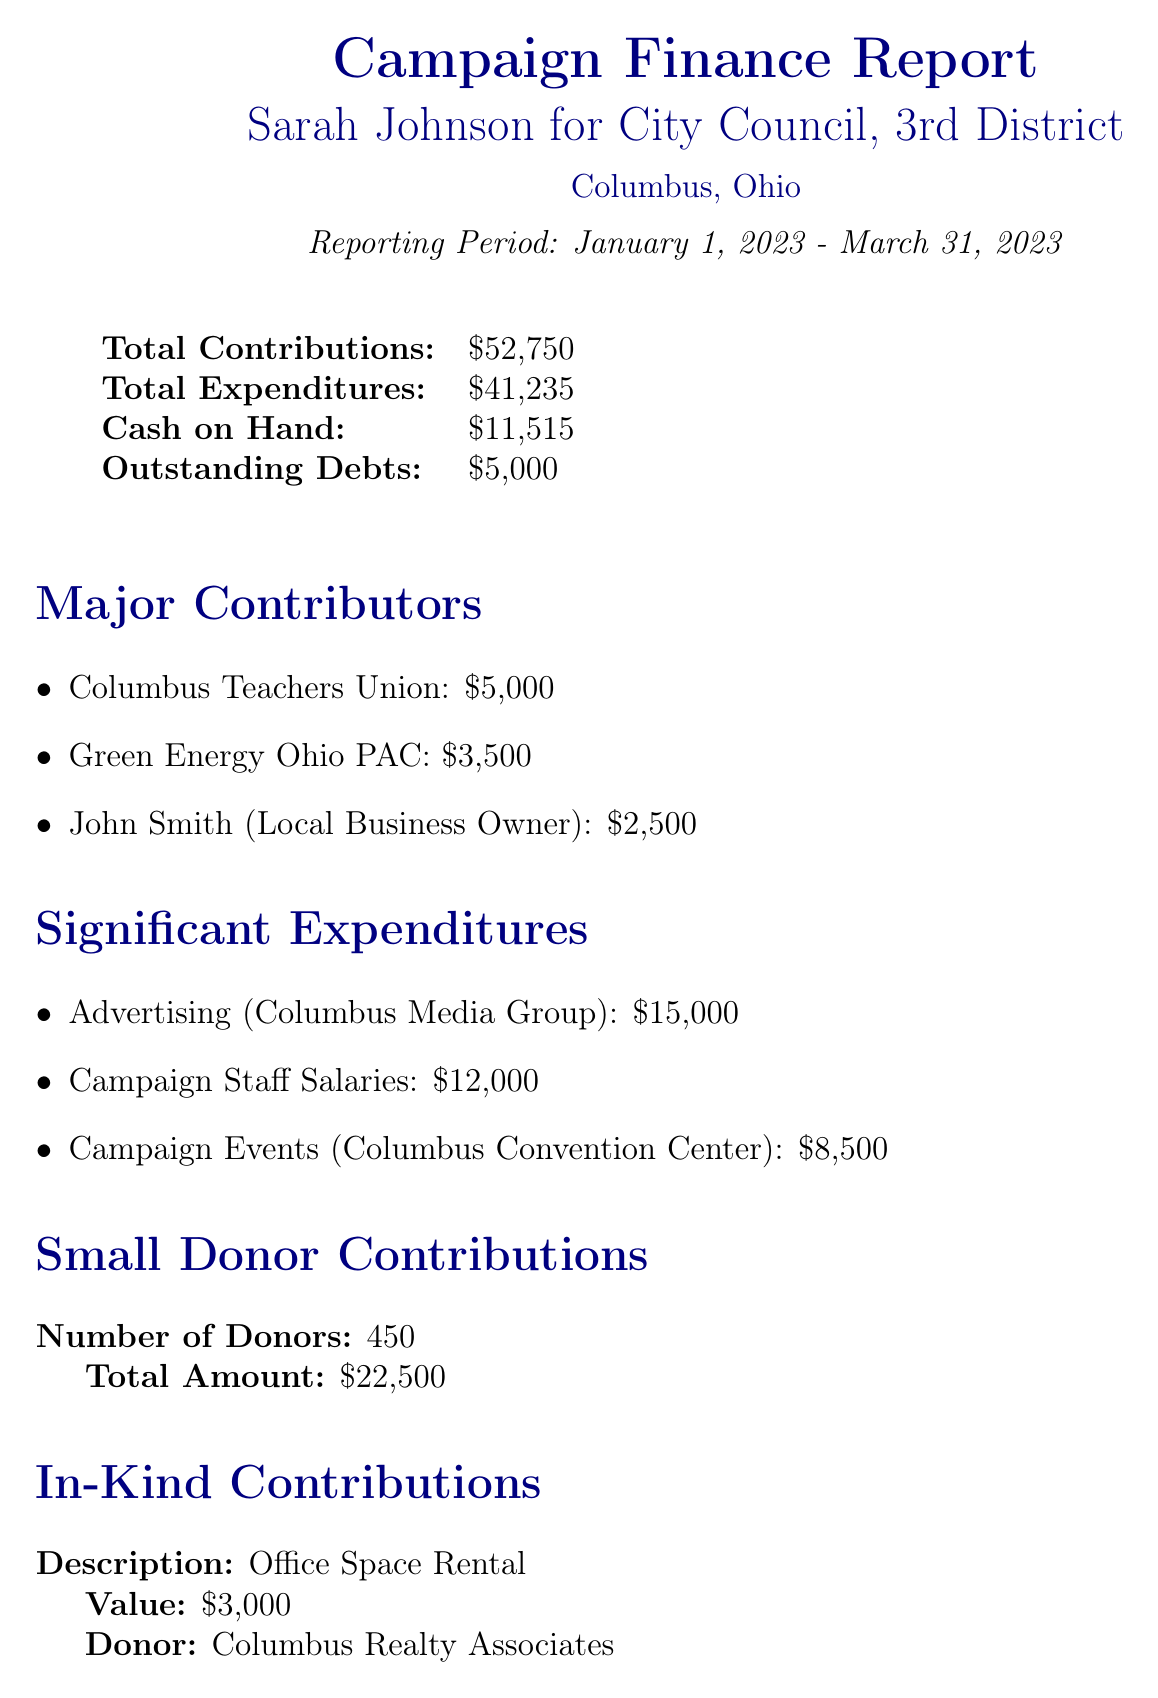What is the total amount of contributions? The total amount of contributions is explicitly listed in the document under "Total Contributions."
Answer: $52,750 Who is the highest contributor? The highest contributor is mentioned under "Major Contributors," with their name and contribution amount detailed.
Answer: Columbus Teachers Union What is the total amount spent on advertising? The total amount spent on advertising is provided under "Significant Expenditures" and can be found in the itemized list.
Answer: $15,000 How many small donors contributed? The total number of small donor contributions is specified in the document.
Answer: 450 What is the value of in-kind contributions? The value of the in-kind contributions is stated in the section titled "In-Kind Contributions."
Answer: $3,000 What was the cash on hand at the end of the reporting period? The cash on hand is mentioned under the financial summary at the beginning of the document.
Answer: $11,515 What are the outstanding debts? The outstanding debts are clearly defined in the document's financial overview.
Answer: $5,000 What is the total amount of small donor contributions? The total amount from small donors can be found in the "Small Donor Contributions" section of the report.
Answer: $22,500 What significant expense is listed regarding campaign events? The significant expense related to campaign events is outlined under "Significant Expenditures," providing specific details.
Answer: $8,500 